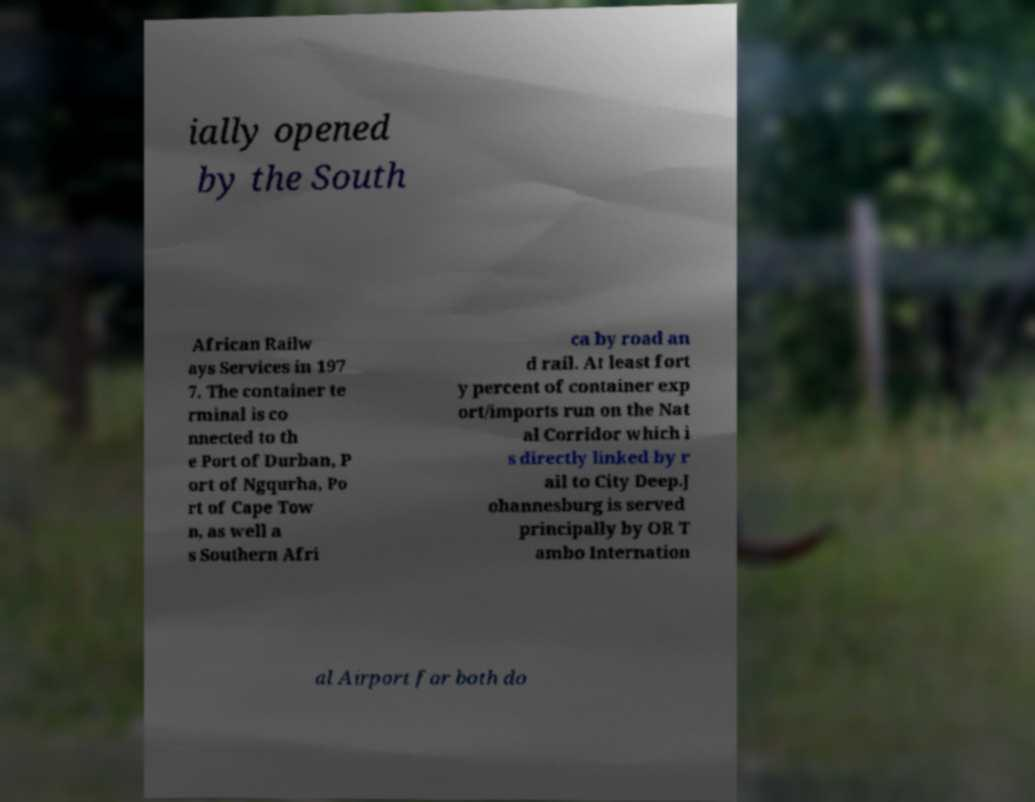Can you read and provide the text displayed in the image?This photo seems to have some interesting text. Can you extract and type it out for me? ially opened by the South African Railw ays Services in 197 7. The container te rminal is co nnected to th e Port of Durban, P ort of Ngqurha, Po rt of Cape Tow n, as well a s Southern Afri ca by road an d rail. At least fort y percent of container exp ort/imports run on the Nat al Corridor which i s directly linked by r ail to City Deep.J ohannesburg is served principally by OR T ambo Internation al Airport for both do 